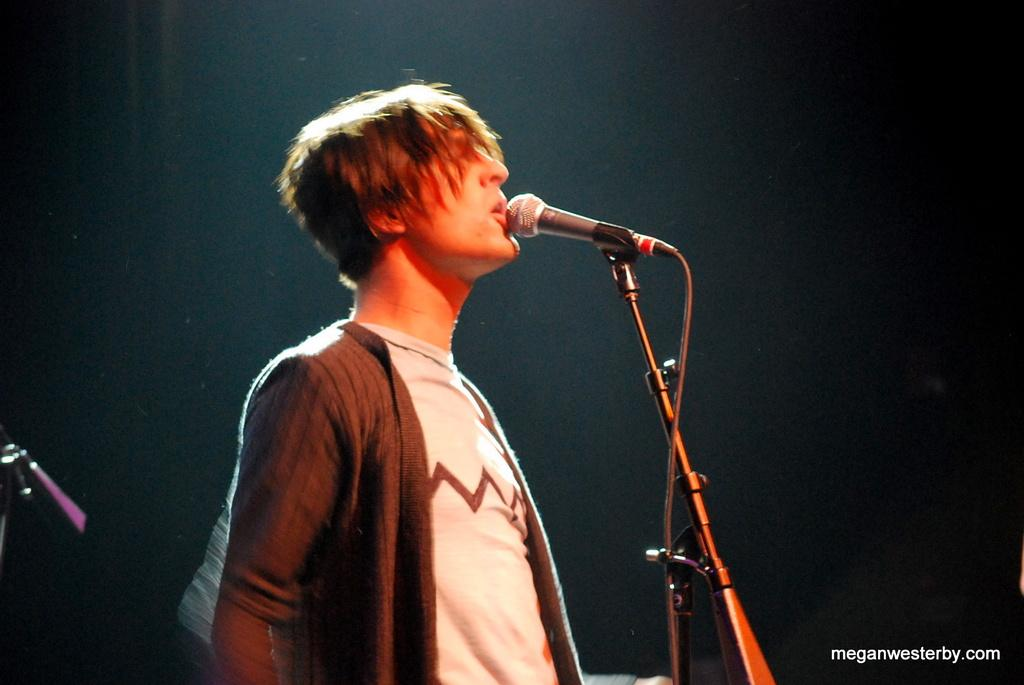What is the man in the image doing? The man is singing in the image. What type of clothing is the man wearing? The man is wearing a t-shirt. What object is present that is typically used for amplifying sound? There is a microphone in the image. How many jellyfish can be seen swimming in the background of the image? There are no jellyfish present in the image; it features a man singing with a microphone. What type of watch is the man wearing in the image? The man is not wearing a watch in the image; only a t-shirt and a microphone are visible. 